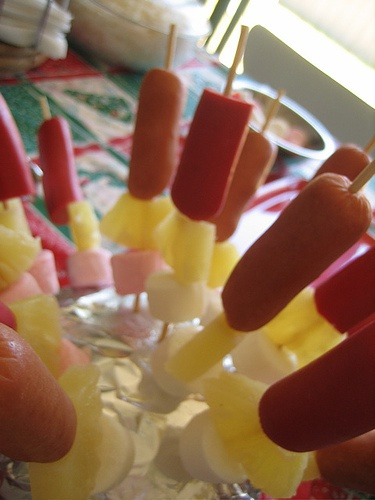Describe the objects in this image and their specific colors. I can see dining table in maroon, black, gray, tan, and olive tones, hot dog in black, maroon, and brown tones, hot dog in black, maroon, olive, and tan tones, hot dog in black, maroon, and brown tones, and banana in black, tan, and olive tones in this image. 